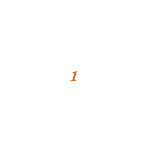Convert code to text. <code><loc_0><loc_0><loc_500><loc_500><_C++_>
</code> 